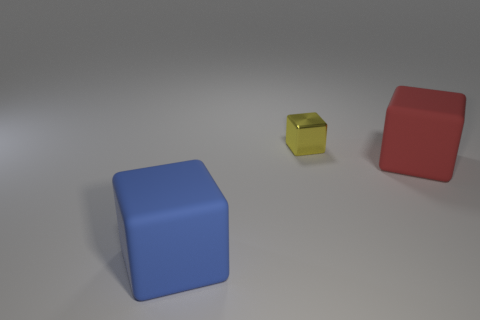Add 2 small brown matte cylinders. How many objects exist? 5 Subtract 1 blue cubes. How many objects are left? 2 Subtract all large red blocks. Subtract all large purple balls. How many objects are left? 2 Add 3 yellow objects. How many yellow objects are left? 4 Add 3 large matte objects. How many large matte objects exist? 5 